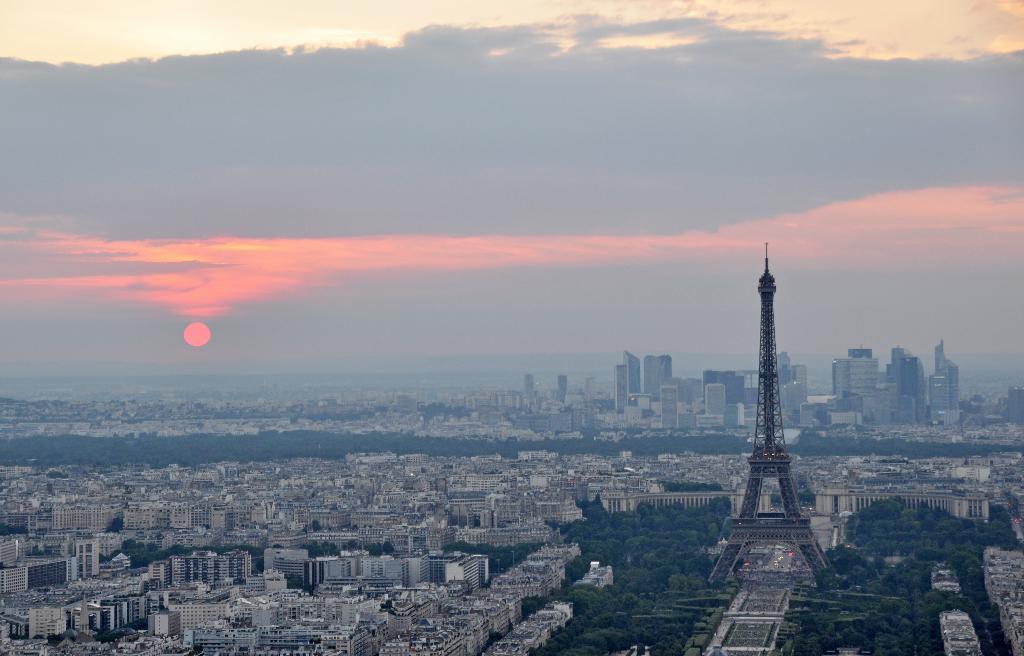Please provide a concise description of this image. In this picture I can observe some buildings and trees. On the right side there is an Eiffel tower. In the background there are some clouds in the sky. I can observe sun in the sky. 